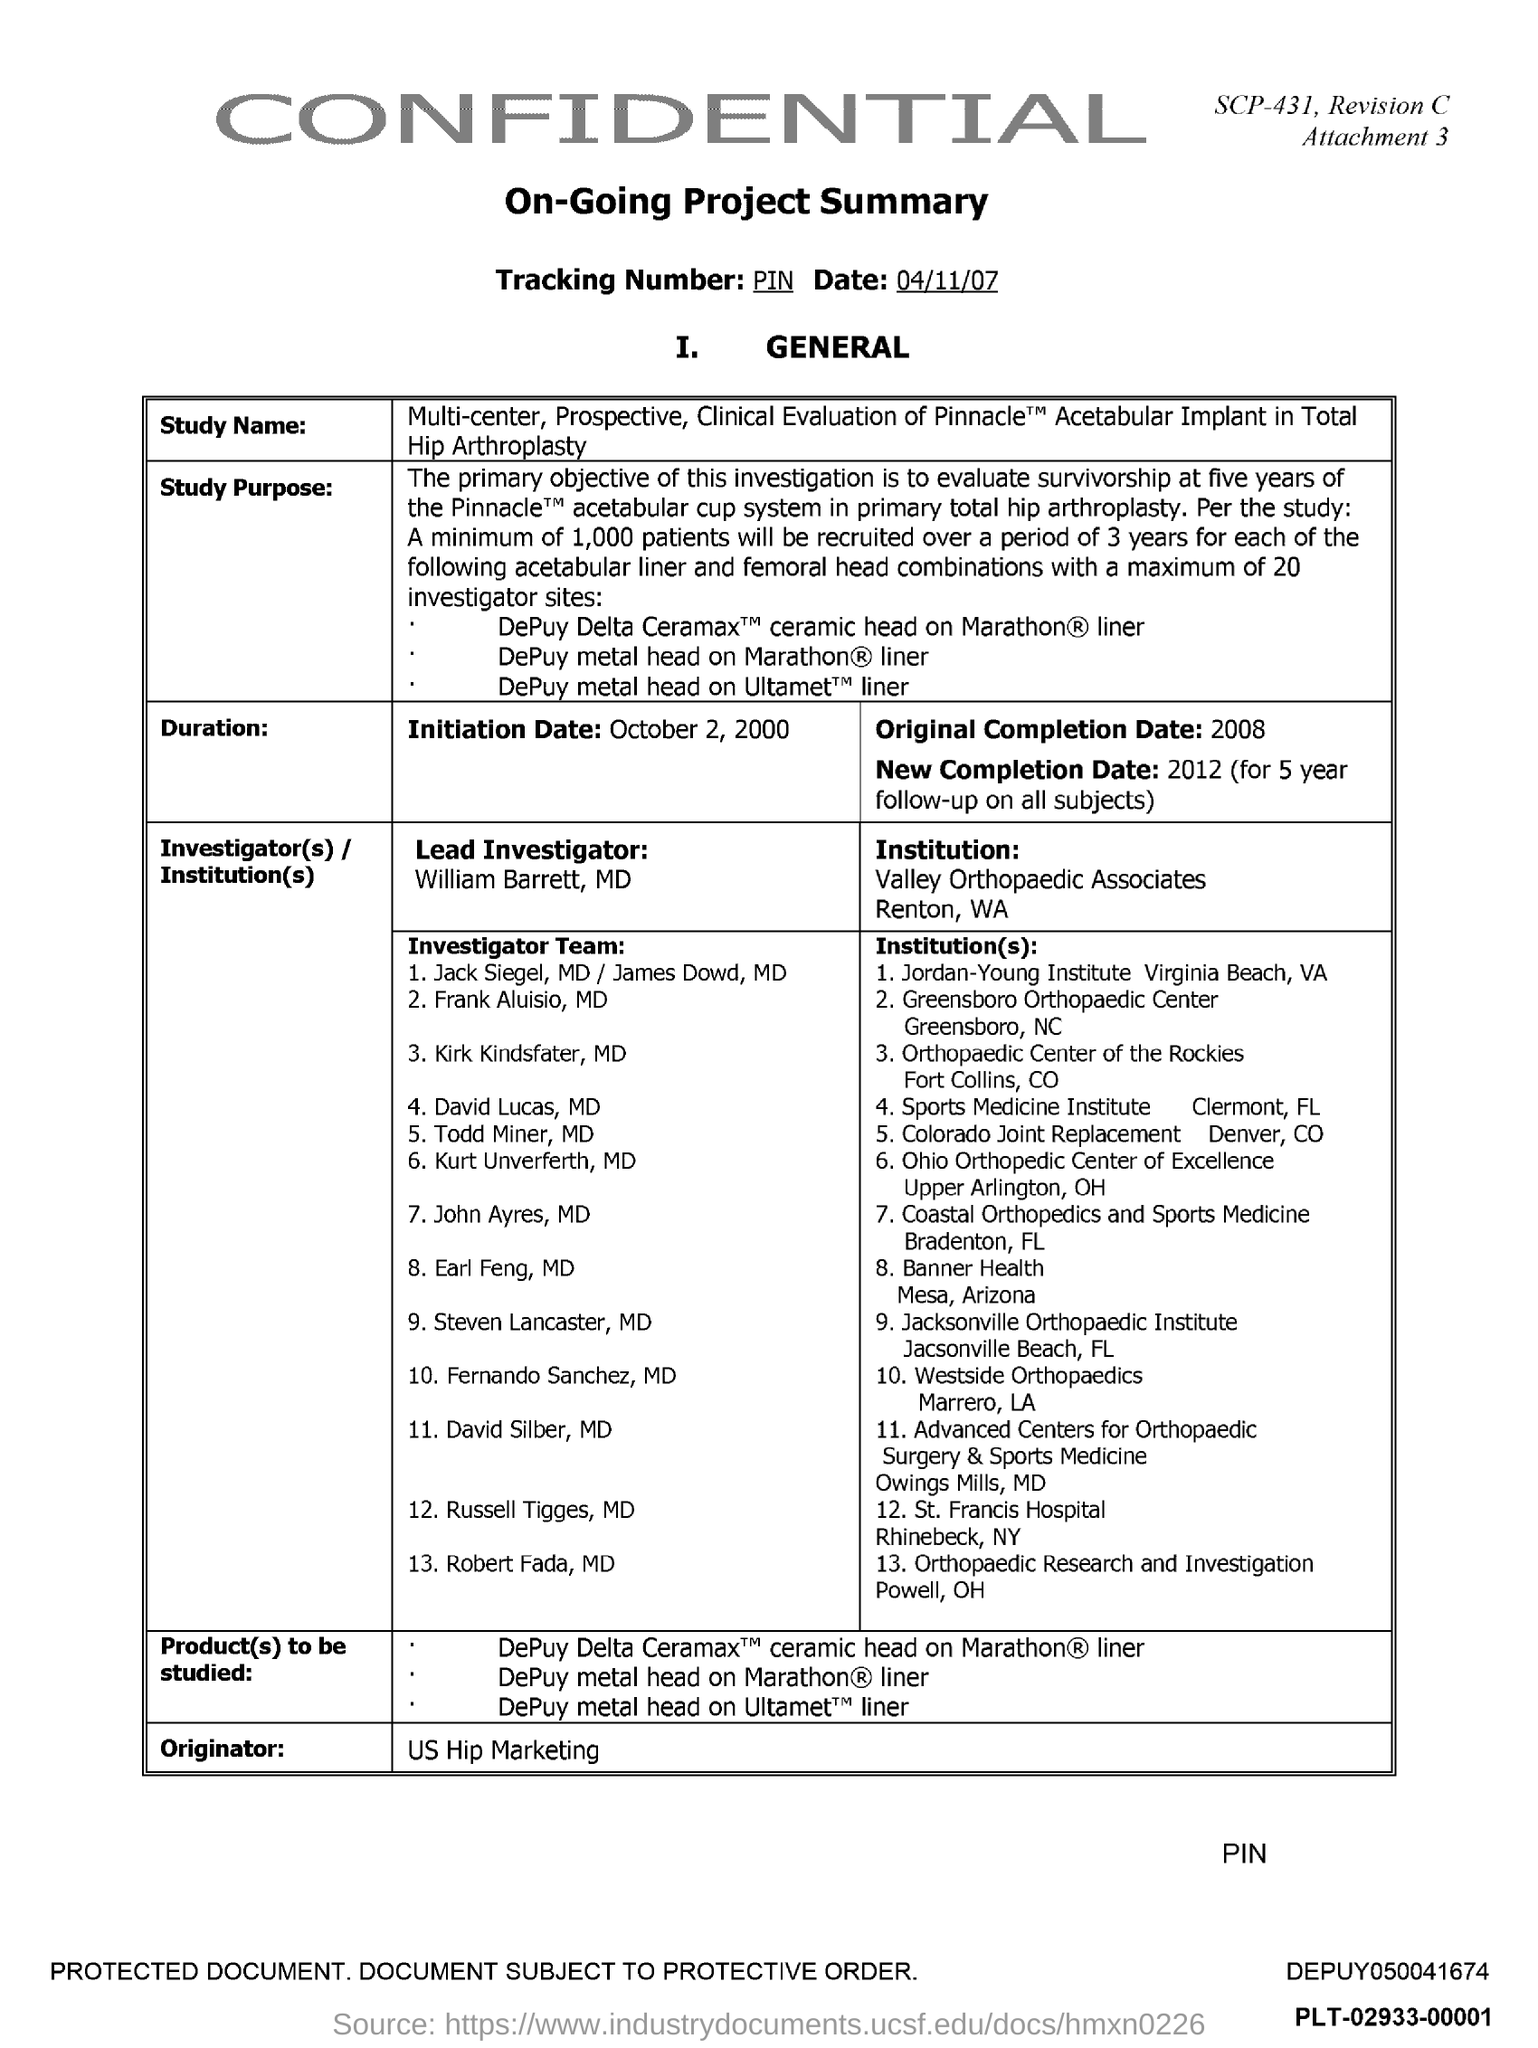What is the initiation date given in the document?
Your response must be concise. October 2, 2000. What is the tracking number given in the document?
Provide a short and direct response. PIN. Who is the lead investigator as per the document?
Your answer should be very brief. William Barrett, MD. Which institution is mentioned in this document?
Offer a very short reply. Valley Orthopaedic Associates, Renton, WA. Who is the Originator mentioned in the dcoument?
Provide a short and direct response. US Hip Marketing. What is the original completion date mentioned in the document?
Give a very brief answer. 2008. 